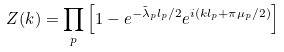<formula> <loc_0><loc_0><loc_500><loc_500>Z ( k ) = \prod _ { p } \left [ 1 - e ^ { - \tilde { \lambda } _ { p } l _ { p } / 2 } e ^ { i ( k l _ { p } + \pi \mu _ { p } / 2 ) } \right ]</formula> 